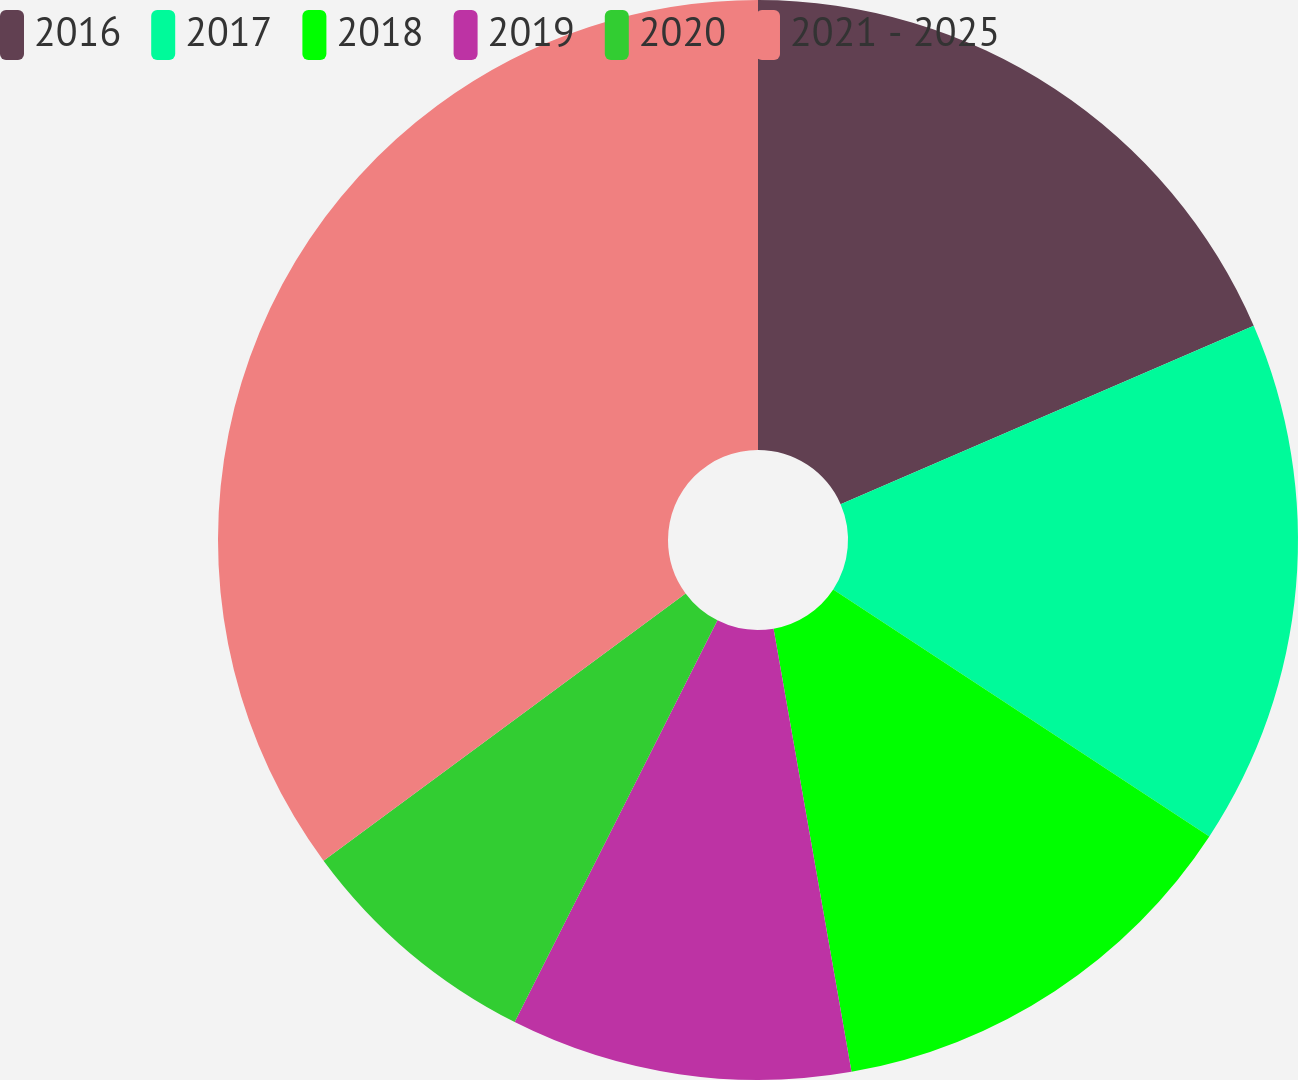Convert chart. <chart><loc_0><loc_0><loc_500><loc_500><pie_chart><fcel>2016<fcel>2017<fcel>2018<fcel>2019<fcel>2020<fcel>2021 - 2025<nl><fcel>18.51%<fcel>15.74%<fcel>12.98%<fcel>10.21%<fcel>7.44%<fcel>35.12%<nl></chart> 